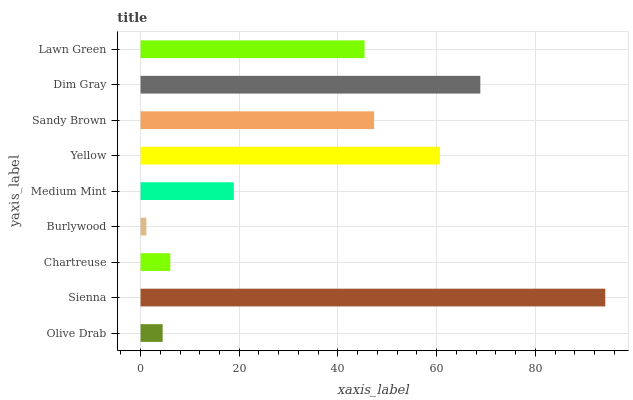Is Burlywood the minimum?
Answer yes or no. Yes. Is Sienna the maximum?
Answer yes or no. Yes. Is Chartreuse the minimum?
Answer yes or no. No. Is Chartreuse the maximum?
Answer yes or no. No. Is Sienna greater than Chartreuse?
Answer yes or no. Yes. Is Chartreuse less than Sienna?
Answer yes or no. Yes. Is Chartreuse greater than Sienna?
Answer yes or no. No. Is Sienna less than Chartreuse?
Answer yes or no. No. Is Lawn Green the high median?
Answer yes or no. Yes. Is Lawn Green the low median?
Answer yes or no. Yes. Is Burlywood the high median?
Answer yes or no. No. Is Sienna the low median?
Answer yes or no. No. 